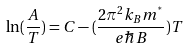<formula> <loc_0><loc_0><loc_500><loc_500>\ln ( \frac { A } { T } ) = C - ( \frac { 2 \pi ^ { 2 } k _ { B } m ^ { ^ { * } } } { e \hbar { B } } ) T</formula> 